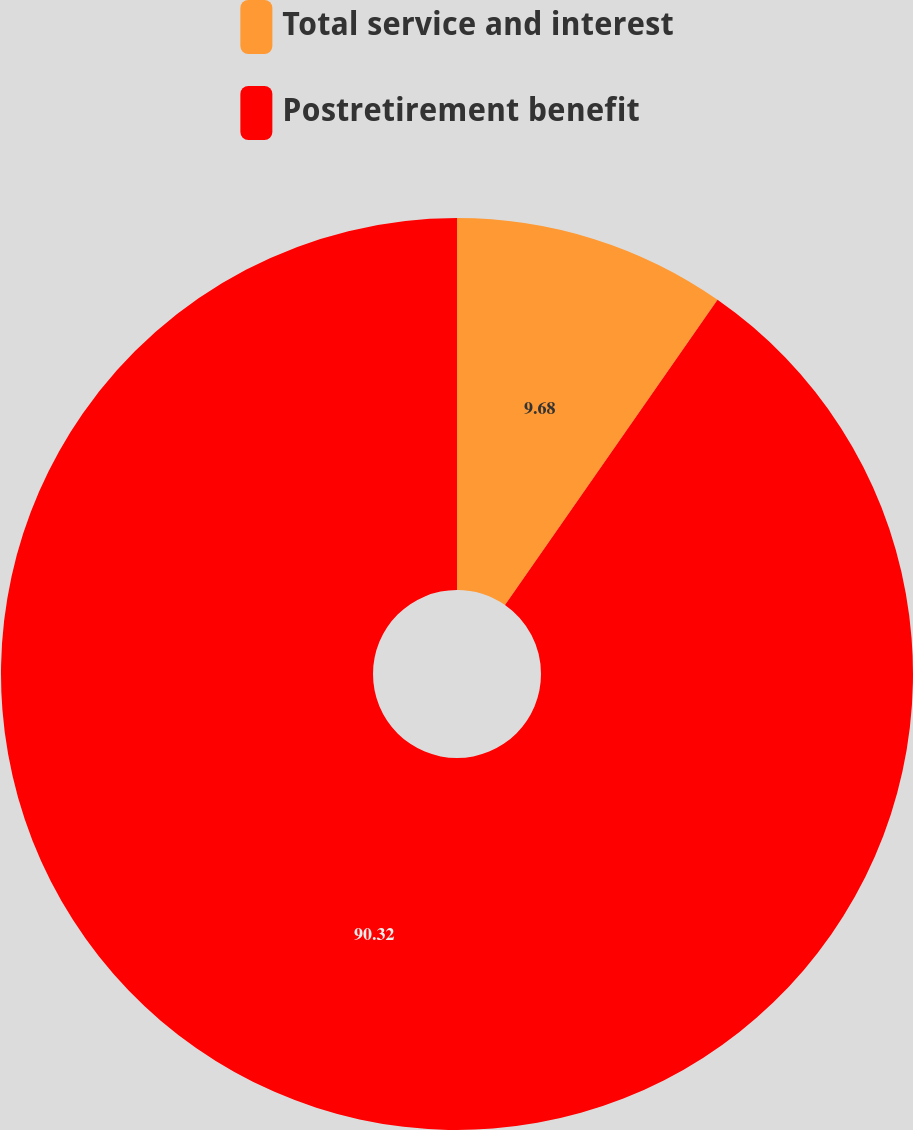<chart> <loc_0><loc_0><loc_500><loc_500><pie_chart><fcel>Total service and interest<fcel>Postretirement benefit<nl><fcel>9.68%<fcel>90.32%<nl></chart> 